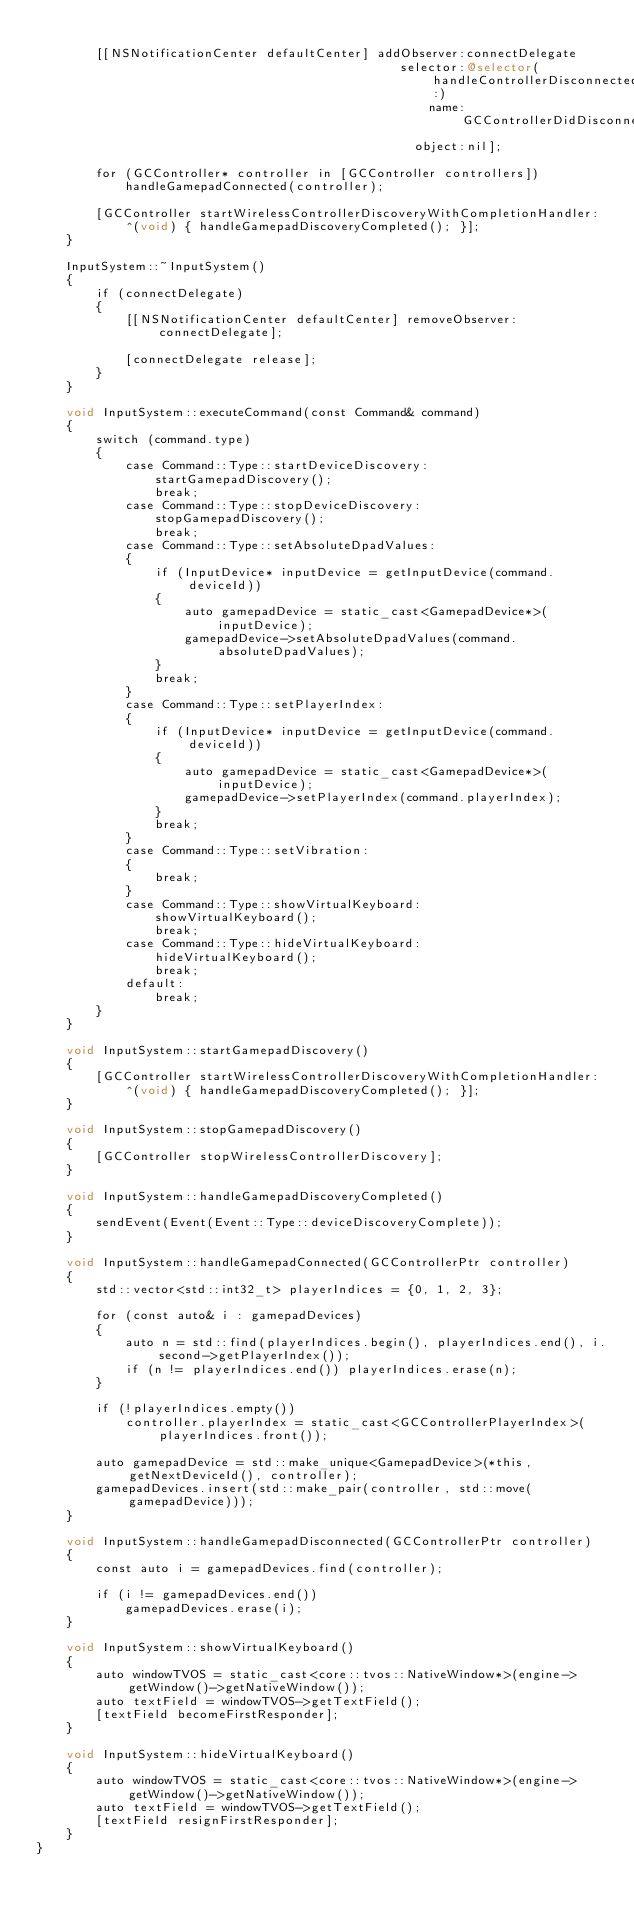<code> <loc_0><loc_0><loc_500><loc_500><_ObjectiveC_>
        [[NSNotificationCenter defaultCenter] addObserver:connectDelegate
                                                 selector:@selector(handleControllerDisconnected:)
                                                     name:GCControllerDidDisconnectNotification
                                                   object:nil];

        for (GCController* controller in [GCController controllers])
            handleGamepadConnected(controller);

        [GCController startWirelessControllerDiscoveryWithCompletionHandler:
            ^(void) { handleGamepadDiscoveryCompleted(); }];
    }

    InputSystem::~InputSystem()
    {
        if (connectDelegate)
        {
            [[NSNotificationCenter defaultCenter] removeObserver:connectDelegate];

            [connectDelegate release];
        }
    }

    void InputSystem::executeCommand(const Command& command)
    {
        switch (command.type)
        {
            case Command::Type::startDeviceDiscovery:
                startGamepadDiscovery();
                break;
            case Command::Type::stopDeviceDiscovery:
                stopGamepadDiscovery();
                break;
            case Command::Type::setAbsoluteDpadValues:
            {
                if (InputDevice* inputDevice = getInputDevice(command.deviceId))
                {
                    auto gamepadDevice = static_cast<GamepadDevice*>(inputDevice);
                    gamepadDevice->setAbsoluteDpadValues(command.absoluteDpadValues);
                }
                break;
            }
            case Command::Type::setPlayerIndex:
            {
                if (InputDevice* inputDevice = getInputDevice(command.deviceId))
                {
                    auto gamepadDevice = static_cast<GamepadDevice*>(inputDevice);
                    gamepadDevice->setPlayerIndex(command.playerIndex);
                }
                break;
            }
            case Command::Type::setVibration:
            {
                break;
            }
            case Command::Type::showVirtualKeyboard:
                showVirtualKeyboard();
                break;
            case Command::Type::hideVirtualKeyboard:
                hideVirtualKeyboard();
                break;
            default:
                break;
        }
    }

    void InputSystem::startGamepadDiscovery()
    {
        [GCController startWirelessControllerDiscoveryWithCompletionHandler:
            ^(void) { handleGamepadDiscoveryCompleted(); }];
    }

    void InputSystem::stopGamepadDiscovery()
    {
        [GCController stopWirelessControllerDiscovery];
    }

    void InputSystem::handleGamepadDiscoveryCompleted()
    {
        sendEvent(Event(Event::Type::deviceDiscoveryComplete));
    }

    void InputSystem::handleGamepadConnected(GCControllerPtr controller)
    {
        std::vector<std::int32_t> playerIndices = {0, 1, 2, 3};

        for (const auto& i : gamepadDevices)
        {
            auto n = std::find(playerIndices.begin(), playerIndices.end(), i.second->getPlayerIndex());
            if (n != playerIndices.end()) playerIndices.erase(n);
        }

        if (!playerIndices.empty())
            controller.playerIndex = static_cast<GCControllerPlayerIndex>(playerIndices.front());

        auto gamepadDevice = std::make_unique<GamepadDevice>(*this, getNextDeviceId(), controller);
        gamepadDevices.insert(std::make_pair(controller, std::move(gamepadDevice)));
    }

    void InputSystem::handleGamepadDisconnected(GCControllerPtr controller)
    {
        const auto i = gamepadDevices.find(controller);

        if (i != gamepadDevices.end())
            gamepadDevices.erase(i);
    }

    void InputSystem::showVirtualKeyboard()
    {
        auto windowTVOS = static_cast<core::tvos::NativeWindow*>(engine->getWindow()->getNativeWindow());
        auto textField = windowTVOS->getTextField();
        [textField becomeFirstResponder];
    }

    void InputSystem::hideVirtualKeyboard()
    {
        auto windowTVOS = static_cast<core::tvos::NativeWindow*>(engine->getWindow()->getNativeWindow());
        auto textField = windowTVOS->getTextField();
        [textField resignFirstResponder];
    }
}
</code> 